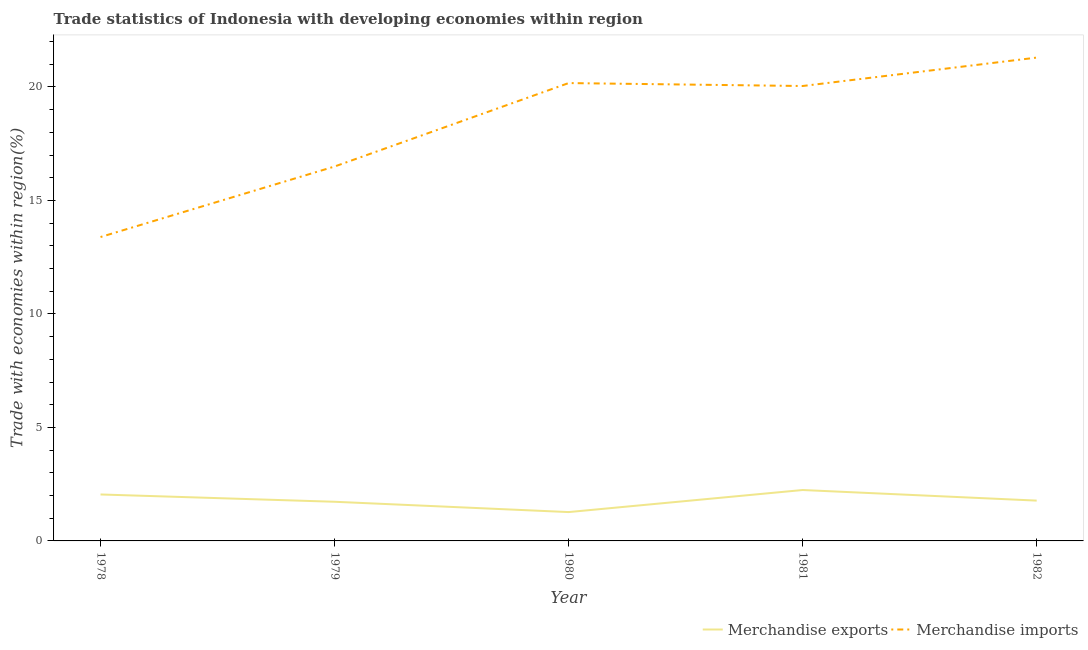How many different coloured lines are there?
Your answer should be very brief. 2. What is the merchandise imports in 1981?
Give a very brief answer. 20.04. Across all years, what is the maximum merchandise imports?
Your response must be concise. 21.29. Across all years, what is the minimum merchandise exports?
Your answer should be compact. 1.27. In which year was the merchandise exports minimum?
Provide a short and direct response. 1980. What is the total merchandise exports in the graph?
Your response must be concise. 9.06. What is the difference between the merchandise imports in 1979 and that in 1980?
Offer a terse response. -3.68. What is the difference between the merchandise imports in 1980 and the merchandise exports in 1981?
Your answer should be compact. 17.93. What is the average merchandise imports per year?
Your response must be concise. 18.28. In the year 1982, what is the difference between the merchandise imports and merchandise exports?
Your answer should be compact. 19.52. In how many years, is the merchandise exports greater than 3 %?
Your response must be concise. 0. What is the ratio of the merchandise exports in 1981 to that in 1982?
Your response must be concise. 1.26. Is the difference between the merchandise exports in 1978 and 1982 greater than the difference between the merchandise imports in 1978 and 1982?
Ensure brevity in your answer.  Yes. What is the difference between the highest and the second highest merchandise imports?
Keep it short and to the point. 1.12. What is the difference between the highest and the lowest merchandise imports?
Provide a succinct answer. 7.9. In how many years, is the merchandise exports greater than the average merchandise exports taken over all years?
Ensure brevity in your answer.  2. Does the merchandise imports monotonically increase over the years?
Offer a very short reply. No. Is the merchandise exports strictly less than the merchandise imports over the years?
Ensure brevity in your answer.  Yes. How many lines are there?
Your response must be concise. 2. How many years are there in the graph?
Provide a short and direct response. 5. Are the values on the major ticks of Y-axis written in scientific E-notation?
Offer a very short reply. No. Does the graph contain grids?
Your answer should be very brief. No. How many legend labels are there?
Offer a terse response. 2. How are the legend labels stacked?
Your answer should be very brief. Horizontal. What is the title of the graph?
Make the answer very short. Trade statistics of Indonesia with developing economies within region. What is the label or title of the Y-axis?
Ensure brevity in your answer.  Trade with economies within region(%). What is the Trade with economies within region(%) of Merchandise exports in 1978?
Your answer should be very brief. 2.05. What is the Trade with economies within region(%) in Merchandise imports in 1978?
Keep it short and to the point. 13.39. What is the Trade with economies within region(%) of Merchandise exports in 1979?
Ensure brevity in your answer.  1.72. What is the Trade with economies within region(%) of Merchandise imports in 1979?
Keep it short and to the point. 16.5. What is the Trade with economies within region(%) of Merchandise exports in 1980?
Your answer should be compact. 1.27. What is the Trade with economies within region(%) of Merchandise imports in 1980?
Offer a very short reply. 20.17. What is the Trade with economies within region(%) of Merchandise exports in 1981?
Your answer should be compact. 2.24. What is the Trade with economies within region(%) of Merchandise imports in 1981?
Your answer should be compact. 20.04. What is the Trade with economies within region(%) of Merchandise exports in 1982?
Offer a terse response. 1.78. What is the Trade with economies within region(%) of Merchandise imports in 1982?
Ensure brevity in your answer.  21.29. Across all years, what is the maximum Trade with economies within region(%) in Merchandise exports?
Ensure brevity in your answer.  2.24. Across all years, what is the maximum Trade with economies within region(%) of Merchandise imports?
Provide a succinct answer. 21.29. Across all years, what is the minimum Trade with economies within region(%) of Merchandise exports?
Your answer should be compact. 1.27. Across all years, what is the minimum Trade with economies within region(%) in Merchandise imports?
Provide a short and direct response. 13.39. What is the total Trade with economies within region(%) in Merchandise exports in the graph?
Give a very brief answer. 9.06. What is the total Trade with economies within region(%) of Merchandise imports in the graph?
Offer a very short reply. 91.39. What is the difference between the Trade with economies within region(%) in Merchandise exports in 1978 and that in 1979?
Your answer should be very brief. 0.32. What is the difference between the Trade with economies within region(%) in Merchandise imports in 1978 and that in 1979?
Your answer should be compact. -3.11. What is the difference between the Trade with economies within region(%) of Merchandise exports in 1978 and that in 1980?
Ensure brevity in your answer.  0.78. What is the difference between the Trade with economies within region(%) of Merchandise imports in 1978 and that in 1980?
Give a very brief answer. -6.78. What is the difference between the Trade with economies within region(%) in Merchandise exports in 1978 and that in 1981?
Your answer should be very brief. -0.2. What is the difference between the Trade with economies within region(%) of Merchandise imports in 1978 and that in 1981?
Make the answer very short. -6.65. What is the difference between the Trade with economies within region(%) of Merchandise exports in 1978 and that in 1982?
Give a very brief answer. 0.27. What is the difference between the Trade with economies within region(%) of Merchandise imports in 1978 and that in 1982?
Offer a very short reply. -7.9. What is the difference between the Trade with economies within region(%) of Merchandise exports in 1979 and that in 1980?
Make the answer very short. 0.45. What is the difference between the Trade with economies within region(%) of Merchandise imports in 1979 and that in 1980?
Ensure brevity in your answer.  -3.68. What is the difference between the Trade with economies within region(%) of Merchandise exports in 1979 and that in 1981?
Offer a terse response. -0.52. What is the difference between the Trade with economies within region(%) of Merchandise imports in 1979 and that in 1981?
Provide a succinct answer. -3.55. What is the difference between the Trade with economies within region(%) of Merchandise exports in 1979 and that in 1982?
Ensure brevity in your answer.  -0.05. What is the difference between the Trade with economies within region(%) in Merchandise imports in 1979 and that in 1982?
Your answer should be very brief. -4.8. What is the difference between the Trade with economies within region(%) in Merchandise exports in 1980 and that in 1981?
Provide a short and direct response. -0.97. What is the difference between the Trade with economies within region(%) in Merchandise imports in 1980 and that in 1981?
Offer a terse response. 0.13. What is the difference between the Trade with economies within region(%) in Merchandise exports in 1980 and that in 1982?
Offer a very short reply. -0.51. What is the difference between the Trade with economies within region(%) in Merchandise imports in 1980 and that in 1982?
Ensure brevity in your answer.  -1.12. What is the difference between the Trade with economies within region(%) in Merchandise exports in 1981 and that in 1982?
Your answer should be very brief. 0.47. What is the difference between the Trade with economies within region(%) of Merchandise imports in 1981 and that in 1982?
Keep it short and to the point. -1.25. What is the difference between the Trade with economies within region(%) in Merchandise exports in 1978 and the Trade with economies within region(%) in Merchandise imports in 1979?
Your response must be concise. -14.45. What is the difference between the Trade with economies within region(%) of Merchandise exports in 1978 and the Trade with economies within region(%) of Merchandise imports in 1980?
Keep it short and to the point. -18.12. What is the difference between the Trade with economies within region(%) in Merchandise exports in 1978 and the Trade with economies within region(%) in Merchandise imports in 1981?
Provide a succinct answer. -18. What is the difference between the Trade with economies within region(%) of Merchandise exports in 1978 and the Trade with economies within region(%) of Merchandise imports in 1982?
Your response must be concise. -19.25. What is the difference between the Trade with economies within region(%) in Merchandise exports in 1979 and the Trade with economies within region(%) in Merchandise imports in 1980?
Offer a terse response. -18.45. What is the difference between the Trade with economies within region(%) of Merchandise exports in 1979 and the Trade with economies within region(%) of Merchandise imports in 1981?
Offer a terse response. -18.32. What is the difference between the Trade with economies within region(%) in Merchandise exports in 1979 and the Trade with economies within region(%) in Merchandise imports in 1982?
Provide a succinct answer. -19.57. What is the difference between the Trade with economies within region(%) in Merchandise exports in 1980 and the Trade with economies within region(%) in Merchandise imports in 1981?
Your answer should be very brief. -18.77. What is the difference between the Trade with economies within region(%) in Merchandise exports in 1980 and the Trade with economies within region(%) in Merchandise imports in 1982?
Make the answer very short. -20.02. What is the difference between the Trade with economies within region(%) in Merchandise exports in 1981 and the Trade with economies within region(%) in Merchandise imports in 1982?
Offer a terse response. -19.05. What is the average Trade with economies within region(%) in Merchandise exports per year?
Give a very brief answer. 1.81. What is the average Trade with economies within region(%) of Merchandise imports per year?
Offer a very short reply. 18.28. In the year 1978, what is the difference between the Trade with economies within region(%) in Merchandise exports and Trade with economies within region(%) in Merchandise imports?
Your response must be concise. -11.34. In the year 1979, what is the difference between the Trade with economies within region(%) of Merchandise exports and Trade with economies within region(%) of Merchandise imports?
Give a very brief answer. -14.77. In the year 1980, what is the difference between the Trade with economies within region(%) of Merchandise exports and Trade with economies within region(%) of Merchandise imports?
Provide a short and direct response. -18.9. In the year 1981, what is the difference between the Trade with economies within region(%) in Merchandise exports and Trade with economies within region(%) in Merchandise imports?
Your response must be concise. -17.8. In the year 1982, what is the difference between the Trade with economies within region(%) in Merchandise exports and Trade with economies within region(%) in Merchandise imports?
Ensure brevity in your answer.  -19.52. What is the ratio of the Trade with economies within region(%) of Merchandise exports in 1978 to that in 1979?
Ensure brevity in your answer.  1.19. What is the ratio of the Trade with economies within region(%) of Merchandise imports in 1978 to that in 1979?
Your answer should be compact. 0.81. What is the ratio of the Trade with economies within region(%) in Merchandise exports in 1978 to that in 1980?
Provide a succinct answer. 1.61. What is the ratio of the Trade with economies within region(%) of Merchandise imports in 1978 to that in 1980?
Give a very brief answer. 0.66. What is the ratio of the Trade with economies within region(%) in Merchandise exports in 1978 to that in 1981?
Offer a terse response. 0.91. What is the ratio of the Trade with economies within region(%) of Merchandise imports in 1978 to that in 1981?
Offer a terse response. 0.67. What is the ratio of the Trade with economies within region(%) of Merchandise exports in 1978 to that in 1982?
Provide a short and direct response. 1.15. What is the ratio of the Trade with economies within region(%) in Merchandise imports in 1978 to that in 1982?
Offer a very short reply. 0.63. What is the ratio of the Trade with economies within region(%) of Merchandise exports in 1979 to that in 1980?
Ensure brevity in your answer.  1.36. What is the ratio of the Trade with economies within region(%) of Merchandise imports in 1979 to that in 1980?
Your response must be concise. 0.82. What is the ratio of the Trade with economies within region(%) of Merchandise exports in 1979 to that in 1981?
Offer a terse response. 0.77. What is the ratio of the Trade with economies within region(%) in Merchandise imports in 1979 to that in 1981?
Your response must be concise. 0.82. What is the ratio of the Trade with economies within region(%) of Merchandise exports in 1979 to that in 1982?
Ensure brevity in your answer.  0.97. What is the ratio of the Trade with economies within region(%) of Merchandise imports in 1979 to that in 1982?
Your response must be concise. 0.77. What is the ratio of the Trade with economies within region(%) of Merchandise exports in 1980 to that in 1981?
Your answer should be very brief. 0.57. What is the ratio of the Trade with economies within region(%) of Merchandise imports in 1980 to that in 1981?
Offer a very short reply. 1.01. What is the ratio of the Trade with economies within region(%) in Merchandise exports in 1980 to that in 1982?
Provide a succinct answer. 0.72. What is the ratio of the Trade with economies within region(%) in Merchandise imports in 1980 to that in 1982?
Keep it short and to the point. 0.95. What is the ratio of the Trade with economies within region(%) in Merchandise exports in 1981 to that in 1982?
Keep it short and to the point. 1.26. What is the ratio of the Trade with economies within region(%) in Merchandise imports in 1981 to that in 1982?
Provide a succinct answer. 0.94. What is the difference between the highest and the second highest Trade with economies within region(%) in Merchandise exports?
Ensure brevity in your answer.  0.2. What is the difference between the highest and the second highest Trade with economies within region(%) of Merchandise imports?
Keep it short and to the point. 1.12. What is the difference between the highest and the lowest Trade with economies within region(%) of Merchandise imports?
Keep it short and to the point. 7.9. 